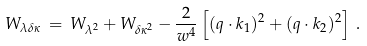<formula> <loc_0><loc_0><loc_500><loc_500>W _ { \lambda \delta \kappa } \, = \, W _ { \lambda ^ { 2 } } + W _ { \delta \kappa ^ { 2 } } - { \frac { 2 } { w ^ { 4 } } } \left [ ( q \cdot k _ { 1 } ) ^ { 2 } + ( q \cdot k _ { 2 } ) ^ { 2 } \right ] \, .</formula> 